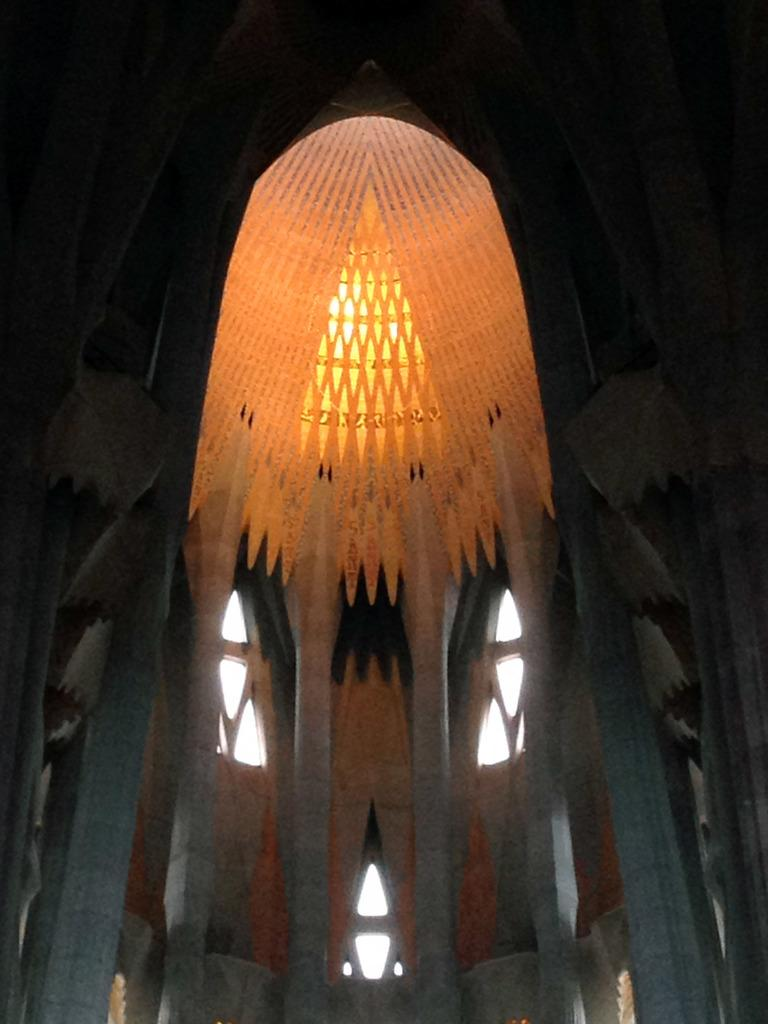What part of a building can be seen in the image? The image shows the inner part of a building. Can you describe the lighting in the image? There is visible light in the image. What color is the sky in the background? The sky in the background appears white in color. What type of whip is being used to control the worms in the image? There are no whips or worms present in the image. 